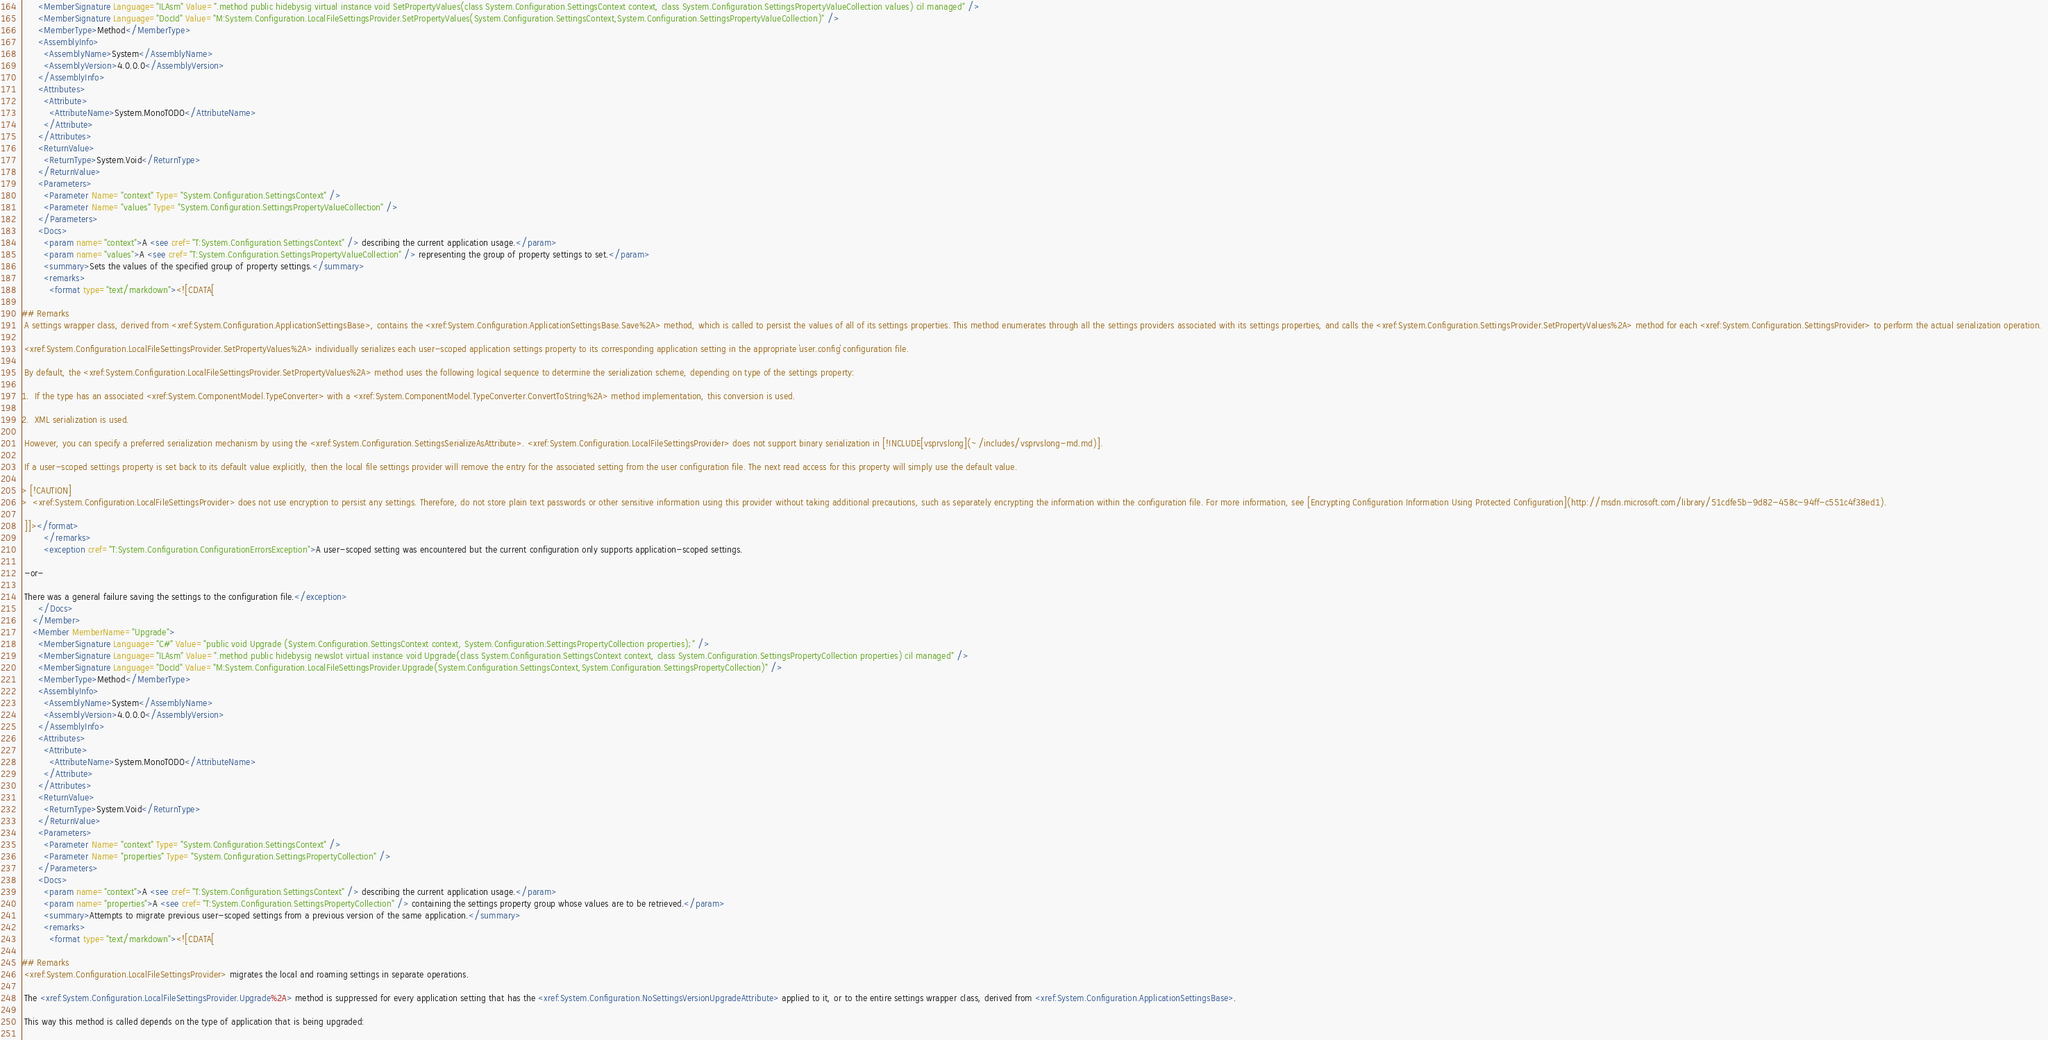Convert code to text. <code><loc_0><loc_0><loc_500><loc_500><_XML_>      <MemberSignature Language="ILAsm" Value=".method public hidebysig virtual instance void SetPropertyValues(class System.Configuration.SettingsContext context, class System.Configuration.SettingsPropertyValueCollection values) cil managed" />
      <MemberSignature Language="DocId" Value="M:System.Configuration.LocalFileSettingsProvider.SetPropertyValues(System.Configuration.SettingsContext,System.Configuration.SettingsPropertyValueCollection)" />
      <MemberType>Method</MemberType>
      <AssemblyInfo>
        <AssemblyName>System</AssemblyName>
        <AssemblyVersion>4.0.0.0</AssemblyVersion>
      </AssemblyInfo>
      <Attributes>
        <Attribute>
          <AttributeName>System.MonoTODO</AttributeName>
        </Attribute>
      </Attributes>
      <ReturnValue>
        <ReturnType>System.Void</ReturnType>
      </ReturnValue>
      <Parameters>
        <Parameter Name="context" Type="System.Configuration.SettingsContext" />
        <Parameter Name="values" Type="System.Configuration.SettingsPropertyValueCollection" />
      </Parameters>
      <Docs>
        <param name="context">A <see cref="T:System.Configuration.SettingsContext" /> describing the current application usage.</param>
        <param name="values">A <see cref="T:System.Configuration.SettingsPropertyValueCollection" /> representing the group of property settings to set.</param>
        <summary>Sets the values of the specified group of property settings.</summary>
        <remarks>
          <format type="text/markdown"><![CDATA[  
  
## Remarks  
 A settings wrapper class, derived from <xref:System.Configuration.ApplicationSettingsBase>, contains the <xref:System.Configuration.ApplicationSettingsBase.Save%2A> method, which is called to persist the values of all of its settings properties. This method enumerates through all the settings providers associated with its settings properties, and calls the <xref:System.Configuration.SettingsProvider.SetPropertyValues%2A> method for each <xref:System.Configuration.SettingsProvider> to perform the actual serialization operation.  
  
 <xref:System.Configuration.LocalFileSettingsProvider.SetPropertyValues%2A> individually serializes each user-scoped application settings property to its corresponding application setting in the appropriate `user.config` configuration file.  
  
 By default, the <xref:System.Configuration.LocalFileSettingsProvider.SetPropertyValues%2A> method uses the following logical sequence to determine the serialization scheme, depending on type of the settings property:  
  
1.  If the type has an associated <xref:System.ComponentModel.TypeConverter> with a <xref:System.ComponentModel.TypeConverter.ConvertToString%2A> method implementation, this conversion is used.  
  
2.  XML serialization is used.  
  
 However, you can specify a preferred serialization mechanism by using the <xref:System.Configuration.SettingsSerializeAsAttribute>. <xref:System.Configuration.LocalFileSettingsProvider> does not support binary serialization in [!INCLUDE[vsprvslong](~/includes/vsprvslong-md.md)].  
  
 If a user-scoped settings property is set back to its default value explicitly, then the local file settings provider will remove the entry for the associated setting from the user configuration file. The next read access for this property will simply use the default value.  
  
> [!CAUTION]
>  <xref:System.Configuration.LocalFileSettingsProvider> does not use encryption to persist any settings. Therefore, do not store plain text passwords or other sensitive information using this provider without taking additional precautions, such as separately encrypting the information within the configuration file. For more information, see [Encrypting Configuration Information Using Protected Configuration](http://msdn.microsoft.com/library/51cdfe5b-9d82-458c-94ff-c551c4f38ed1).  
  
 ]]></format>
        </remarks>
        <exception cref="T:System.Configuration.ConfigurationErrorsException">A user-scoped setting was encountered but the current configuration only supports application-scoped settings.  
  
 -or-  
  
 There was a general failure saving the settings to the configuration file.</exception>
      </Docs>
    </Member>
    <Member MemberName="Upgrade">
      <MemberSignature Language="C#" Value="public void Upgrade (System.Configuration.SettingsContext context, System.Configuration.SettingsPropertyCollection properties);" />
      <MemberSignature Language="ILAsm" Value=".method public hidebysig newslot virtual instance void Upgrade(class System.Configuration.SettingsContext context, class System.Configuration.SettingsPropertyCollection properties) cil managed" />
      <MemberSignature Language="DocId" Value="M:System.Configuration.LocalFileSettingsProvider.Upgrade(System.Configuration.SettingsContext,System.Configuration.SettingsPropertyCollection)" />
      <MemberType>Method</MemberType>
      <AssemblyInfo>
        <AssemblyName>System</AssemblyName>
        <AssemblyVersion>4.0.0.0</AssemblyVersion>
      </AssemblyInfo>
      <Attributes>
        <Attribute>
          <AttributeName>System.MonoTODO</AttributeName>
        </Attribute>
      </Attributes>
      <ReturnValue>
        <ReturnType>System.Void</ReturnType>
      </ReturnValue>
      <Parameters>
        <Parameter Name="context" Type="System.Configuration.SettingsContext" />
        <Parameter Name="properties" Type="System.Configuration.SettingsPropertyCollection" />
      </Parameters>
      <Docs>
        <param name="context">A <see cref="T:System.Configuration.SettingsContext" /> describing the current application usage.</param>
        <param name="properties">A <see cref="T:System.Configuration.SettingsPropertyCollection" /> containing the settings property group whose values are to be retrieved.</param>
        <summary>Attempts to migrate previous user-scoped settings from a previous version of the same application.</summary>
        <remarks>
          <format type="text/markdown"><![CDATA[  
  
## Remarks  
 <xref:System.Configuration.LocalFileSettingsProvider> migrates the local and roaming settings in separate operations.  
  
 The <xref:System.Configuration.LocalFileSettingsProvider.Upgrade%2A> method is suppressed for every application setting that has the <xref:System.Configuration.NoSettingsVersionUpgradeAttribute> applied to it, or to the entire settings wrapper class, derived from <xref:System.Configuration.ApplicationSettingsBase>.  
  
 This way this method is called depends on the type of application that is being upgraded:  
  </code> 